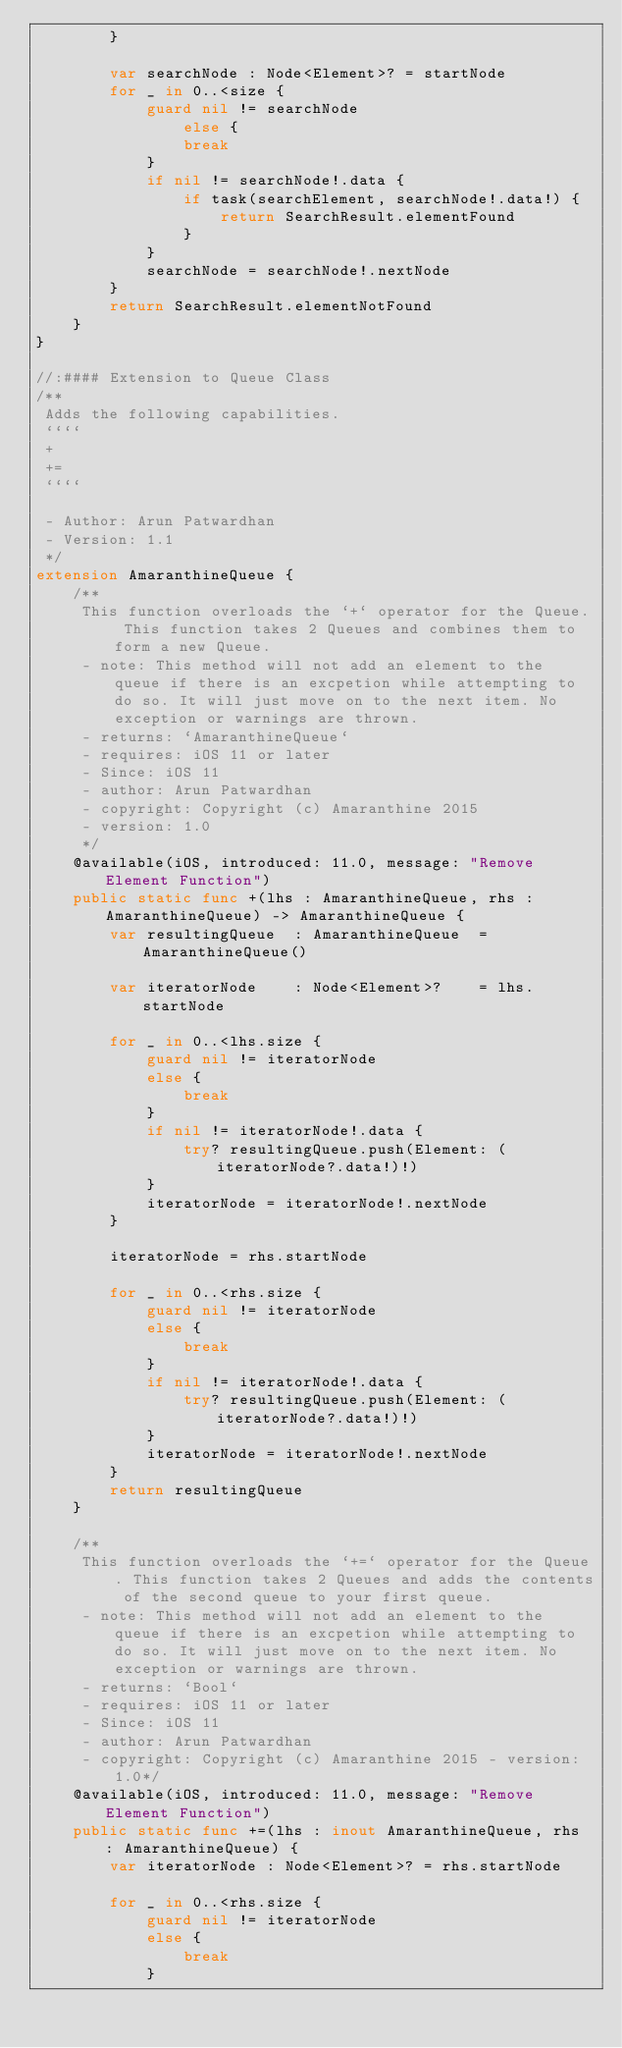<code> <loc_0><loc_0><loc_500><loc_500><_Swift_>        }
        
        var searchNode : Node<Element>? = startNode
        for _ in 0..<size {
            guard nil != searchNode
                else {
                break
            }
            if nil != searchNode!.data {
                if task(searchElement, searchNode!.data!) {
                    return SearchResult.elementFound
                }
            }
            searchNode = searchNode!.nextNode
        }
        return SearchResult.elementNotFound
    }
}

//:#### Extension to Queue Class
/**
 Adds the following capabilities.
 ````
 +
 +=
 ````
 
 - Author: Arun Patwardhan
 - Version: 1.1
 */
extension AmaranthineQueue {
    /**
     This function overloads the `+` operator for the Queue. This function takes 2 Queues and combines them to form a new Queue.
     - note: This method will not add an element to the queue if there is an excpetion while attempting to do so. It will just move on to the next item. No exception or warnings are thrown.
     - returns: `AmaranthineQueue`
     - requires: iOS 11 or later
     - Since: iOS 11
     - author: Arun Patwardhan
     - copyright: Copyright (c) Amaranthine 2015
     - version: 1.0
     */
    @available(iOS, introduced: 11.0, message: "Remove Element Function")
    public static func +(lhs : AmaranthineQueue, rhs : AmaranthineQueue) -> AmaranthineQueue {
        var resultingQueue  : AmaranthineQueue  = AmaranthineQueue()
        
        var iteratorNode    : Node<Element>?    = lhs.startNode
        
        for _ in 0..<lhs.size {
            guard nil != iteratorNode
            else {
                break
            }
            if nil != iteratorNode!.data {
                try? resultingQueue.push(Element: (iteratorNode?.data!)!)
            }
            iteratorNode = iteratorNode!.nextNode
        }
        
        iteratorNode = rhs.startNode
        
        for _ in 0..<rhs.size {
            guard nil != iteratorNode
            else {
                break
            }
            if nil != iteratorNode!.data {
                try? resultingQueue.push(Element: (iteratorNode?.data!)!)
            }
            iteratorNode = iteratorNode!.nextNode
        }
        return resultingQueue
    }
    
    /**
     This function overloads the `+=` operator for the Queue. This function takes 2 Queues and adds the contents of the second queue to your first queue.
     - note: This method will not add an element to the queue if there is an excpetion while attempting to do so. It will just move on to the next item. No exception or warnings are thrown.
     - returns: `Bool`
     - requires: iOS 11 or later
     - Since: iOS 11
     - author: Arun Patwardhan
     - copyright: Copyright (c) Amaranthine 2015 - version: 1.0*/
    @available(iOS, introduced: 11.0, message: "Remove Element Function")
    public static func +=(lhs : inout AmaranthineQueue, rhs : AmaranthineQueue) {
        var iteratorNode : Node<Element>? = rhs.startNode
        
        for _ in 0..<rhs.size {
            guard nil != iteratorNode
            else {
                break
            }</code> 